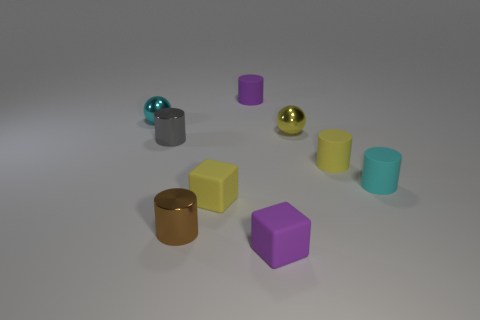Subtract all yellow cylinders. How many cylinders are left? 4 Subtract all gray cylinders. How many cylinders are left? 4 Subtract 2 cylinders. How many cylinders are left? 3 Subtract all cyan cylinders. Subtract all cyan balls. How many cylinders are left? 4 Subtract all blocks. How many objects are left? 7 Subtract all tiny rubber objects. Subtract all large blue metal cubes. How many objects are left? 4 Add 7 small yellow rubber objects. How many small yellow rubber objects are left? 9 Add 8 purple matte things. How many purple matte things exist? 10 Subtract 0 gray blocks. How many objects are left? 9 